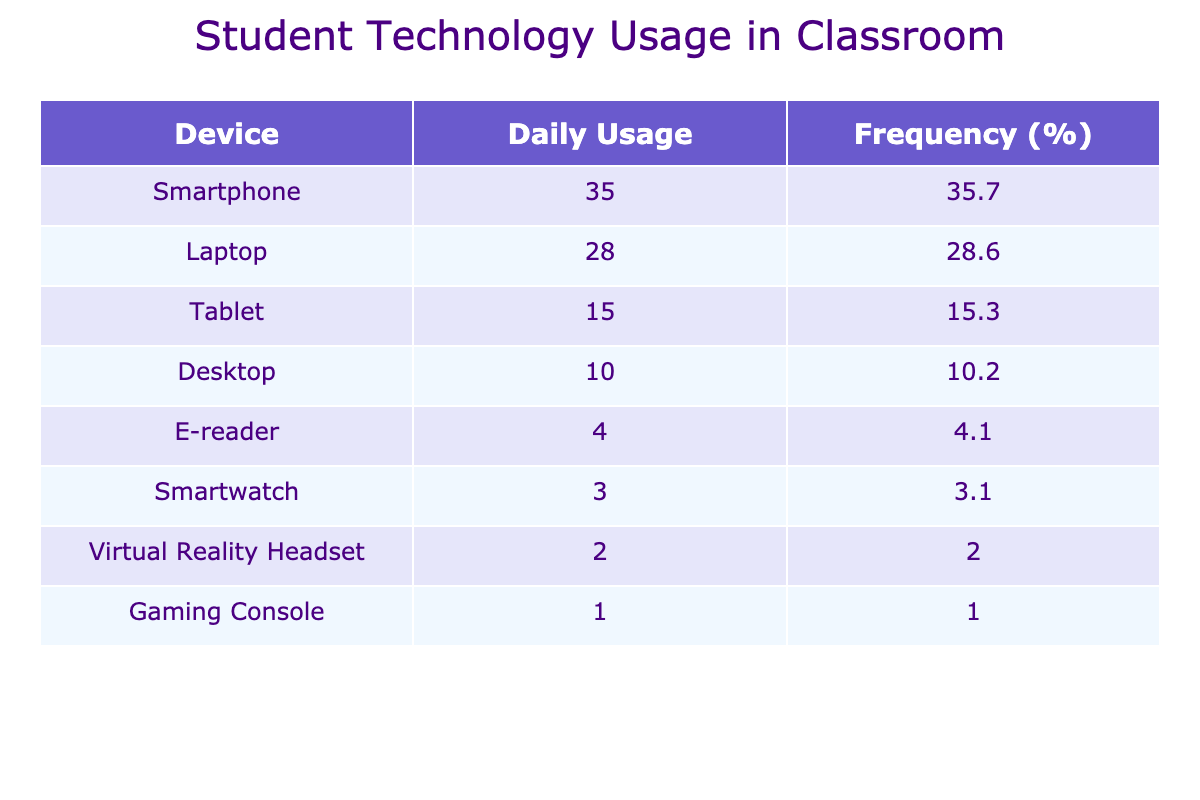What device has the highest daily usage? The table shows the usage frequency, and the device with the highest frequency is the smartphone with a daily usage of 35.
Answer: Smartphone What is the total number of students using technology in the classroom? To find the total, we sum the daily usage values: 35 + 28 + 15 + 10 + 3 + 4 + 2 + 1 = 98.
Answer: 98 Which device has the least daily usage? By looking at the usage frequency, the device with the least usage is the gaming console with a daily usage of 1.
Answer: Gaming Console Is the usage of tablets higher than that of desktops? The table shows that tablets have a daily usage frequency of 15, while desktops have a frequency of 10. Since 15 is greater than 10, the statement is true.
Answer: Yes What percentage of daily usage does the laptop represent? The daily usage for laptops is 28. The total usage is 98, so to find the percentage, calculate (28/98) * 100 = 28.6%.
Answer: 28.6 How much more frequent is smartphone usage compared to smartwatch usage? The smartphone usage is 35, and the smartwatch usage is 3. To find the difference, we subtract: 35 - 3 = 32. Therefore, smartphone usage is 32 more frequent than smartwatch usage.
Answer: 32 If we combine the usage of e-readers and smartwatches, how does it compare to the usage of virtual reality headsets? E-readers have a usage of 4, and smartwatches have a usage of 3. Combined they total 4 + 3 = 7. The virtual reality headset has a usage of 2. Since 7 is greater than 2, the combined usage is higher.
Answer: Higher What is the percentage of total usage accounted for by desktops? Desktops have a daily usage of 10. Calculating the percentage: (10/98) * 100 = 10.2%.
Answer: 10.2 If we ranked the devices from most to least used, which device holds the second place? Based on the usage frequencies, the smartphone is first (35), and the laptop is second with 28.
Answer: Laptop 